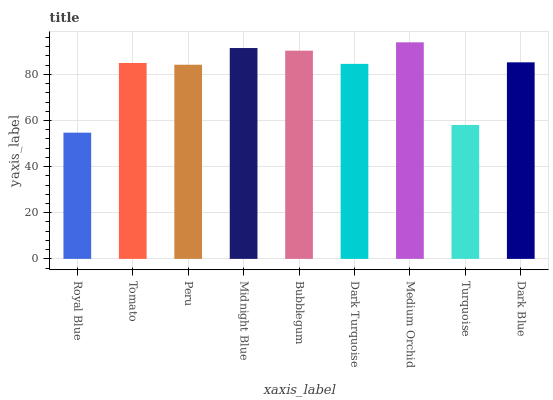Is Royal Blue the minimum?
Answer yes or no. Yes. Is Medium Orchid the maximum?
Answer yes or no. Yes. Is Tomato the minimum?
Answer yes or no. No. Is Tomato the maximum?
Answer yes or no. No. Is Tomato greater than Royal Blue?
Answer yes or no. Yes. Is Royal Blue less than Tomato?
Answer yes or no. Yes. Is Royal Blue greater than Tomato?
Answer yes or no. No. Is Tomato less than Royal Blue?
Answer yes or no. No. Is Tomato the high median?
Answer yes or no. Yes. Is Tomato the low median?
Answer yes or no. Yes. Is Medium Orchid the high median?
Answer yes or no. No. Is Peru the low median?
Answer yes or no. No. 